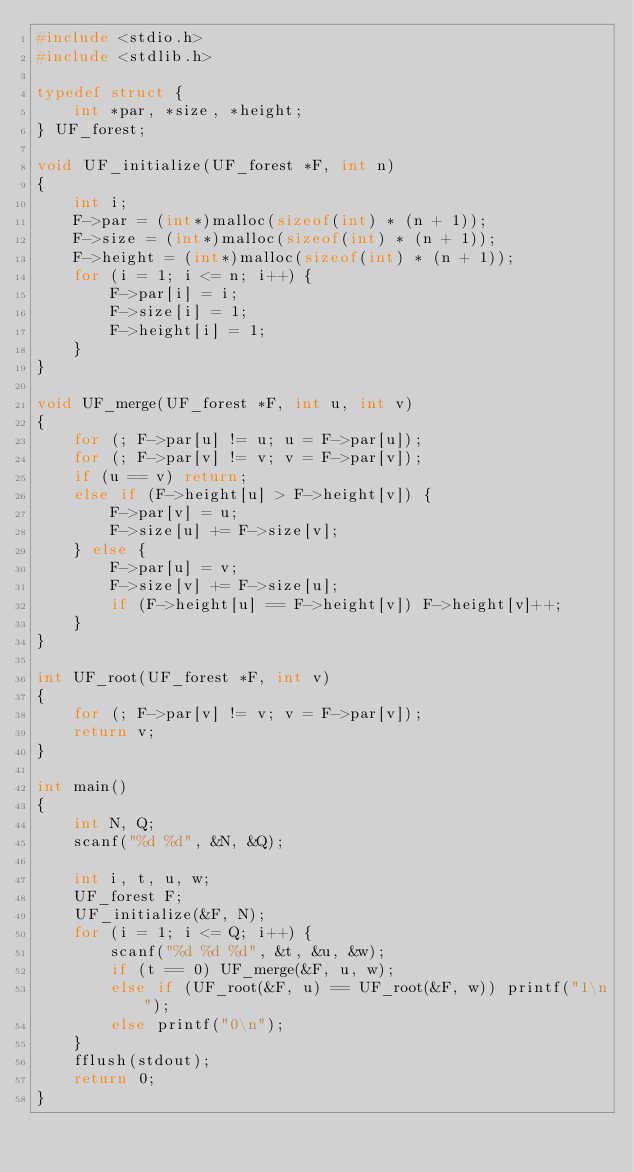<code> <loc_0><loc_0><loc_500><loc_500><_C_>#include <stdio.h>
#include <stdlib.h>

typedef struct {
	int *par, *size, *height;
} UF_forest;

void UF_initialize(UF_forest *F, int n)
{
	int i;
	F->par = (int*)malloc(sizeof(int) * (n + 1));
	F->size = (int*)malloc(sizeof(int) * (n + 1));
	F->height = (int*)malloc(sizeof(int) * (n + 1));
	for (i = 1; i <= n; i++) {
		F->par[i] = i;
		F->size[i] = 1;
		F->height[i] = 1;
	}
}

void UF_merge(UF_forest *F, int u, int v)
{
	for (; F->par[u] != u; u = F->par[u]);
	for (; F->par[v] != v; v = F->par[v]);
	if (u == v) return;
	else if (F->height[u] > F->height[v]) {
		F->par[v] = u;
		F->size[u] += F->size[v];
	} else {
		F->par[u] = v;
		F->size[v] += F->size[u];
		if (F->height[u] == F->height[v]) F->height[v]++;
	}
}

int UF_root(UF_forest *F, int v)
{
	for (; F->par[v] != v; v = F->par[v]);
	return v;
}

int main()
{
	int N, Q;
	scanf("%d %d", &N, &Q);
	
	int i, t, u, w;
	UF_forest F;
	UF_initialize(&F, N);
	for (i = 1; i <= Q; i++) {
		scanf("%d %d %d", &t, &u, &w);
		if (t == 0) UF_merge(&F, u, w);
		else if (UF_root(&F, u) == UF_root(&F, w)) printf("1\n");
		else printf("0\n");
	}
	fflush(stdout);
	return 0;
}</code> 